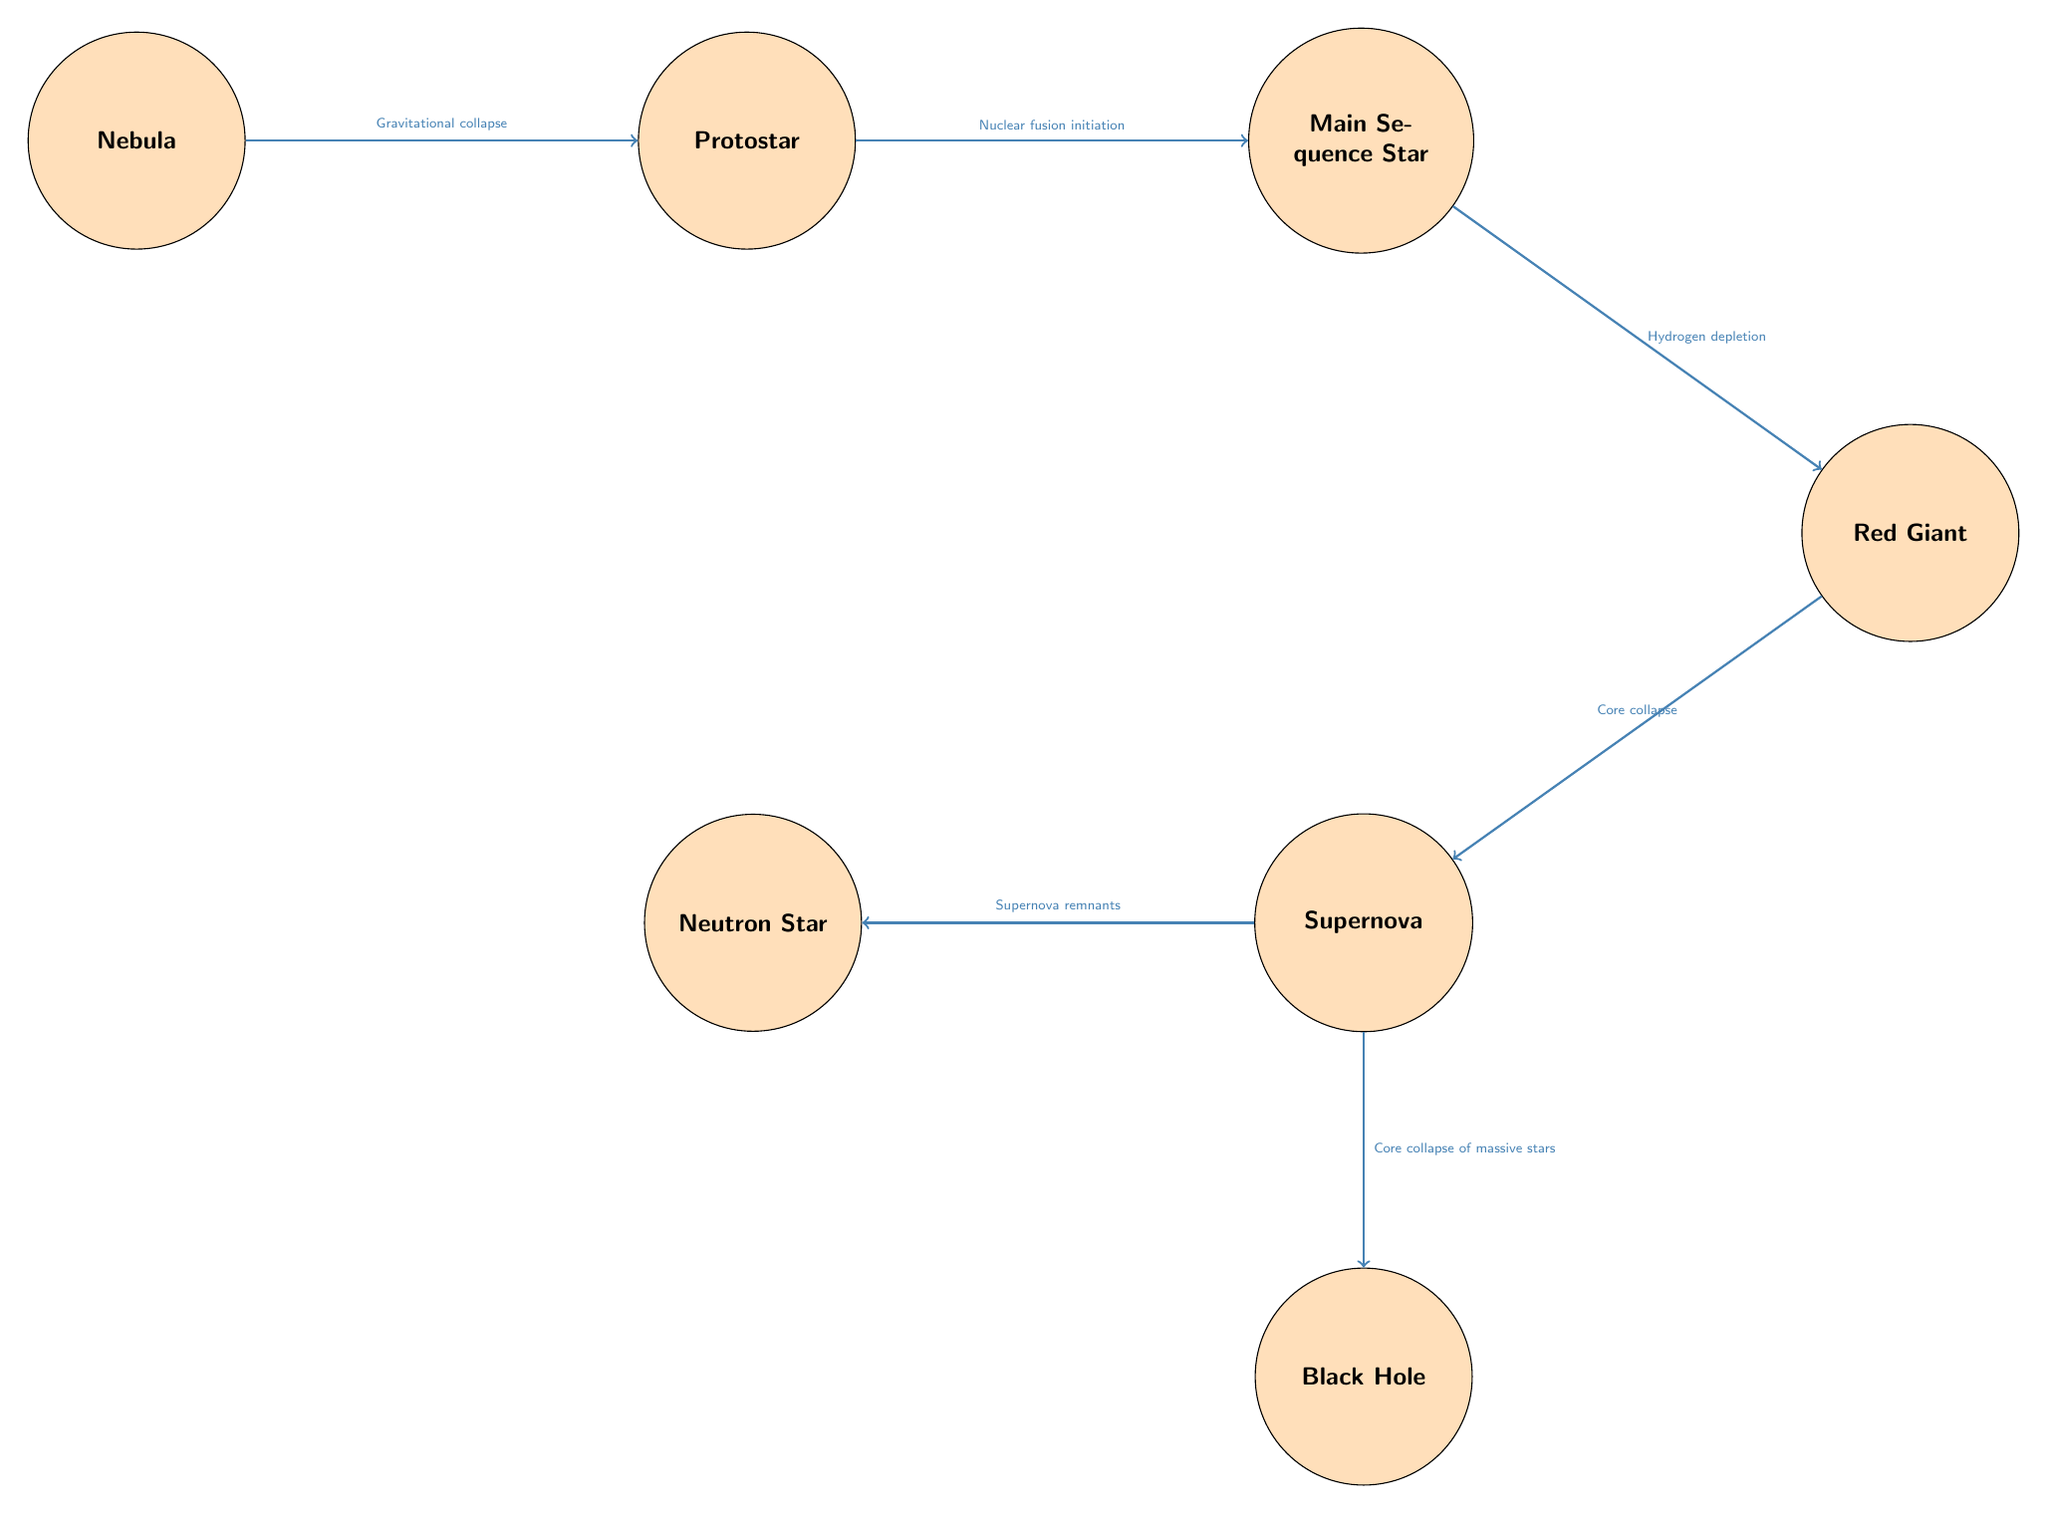What is the first stage in the life cycle of a star? The diagram shows "Nebula" as the first node, which represents the initial stage in the life cycle of a star.
Answer: Nebula How many main stages of star life cycle are represented in the diagram? The diagram includes seven distinct nodes representing stages in the life cycle of a star, indicating that there are seven main stages.
Answer: Seven What process leads from Nebula to Protostar? The arrow between "Nebula" and "Protostar" indicates that "Gravitational collapse" is the process that leads to the formation of a protostar.
Answer: Gravitational collapse What happens in the Main Sequence phase? The description for "Main Sequence Star" states that this phase involves "Nuclear fusion initiation," where the star converts hydrogen to helium.
Answer: Nuclear fusion initiation Which stage has a branch leading to both Neutron Star and Black Hole? The diagram shows that "Supernova" has two arrows branching out, one leading to "Neutron Star" and the other to "Black Hole," indicating it is a pivotal stage that can lead to either outcome.
Answer: Supernova What occurs during the Red Giant phase? The description for "Red Giant" states that during this stage, the star expands and starts "fusing helium" after depleting its hydrogen fuel.
Answer: Fusing helium What is the final outcome of a star's life cycle based on its mass? The flow from "Supernova" illustrates that the end of a massive star's life can lead to a "Black Hole," while less massive ones result in a "Neutron Star."
Answer: Black Hole Which stage signifies the end of a massive star's life? The diagram clearly indicates that "Supernova" is the event that signifies the end of a massive star's life cycle.
Answer: Supernova What is formed after the core collapse during the Red Giant phase? According to the diagram, the transition from "Red Giant" leads to "Supernova," indicating that a Supernova is formed as a result of core collapse.
Answer: Supernova 